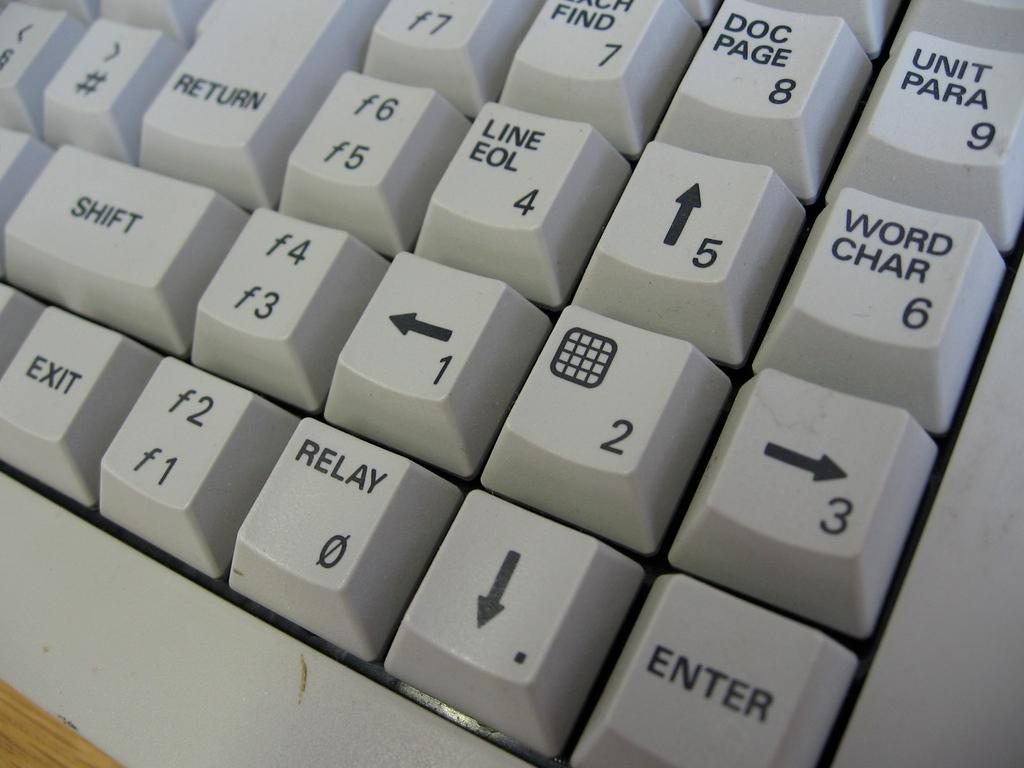<image>
Relay a brief, clear account of the picture shown. A white keyboard with a button that says Return at the top and Shift underneath it. it. 